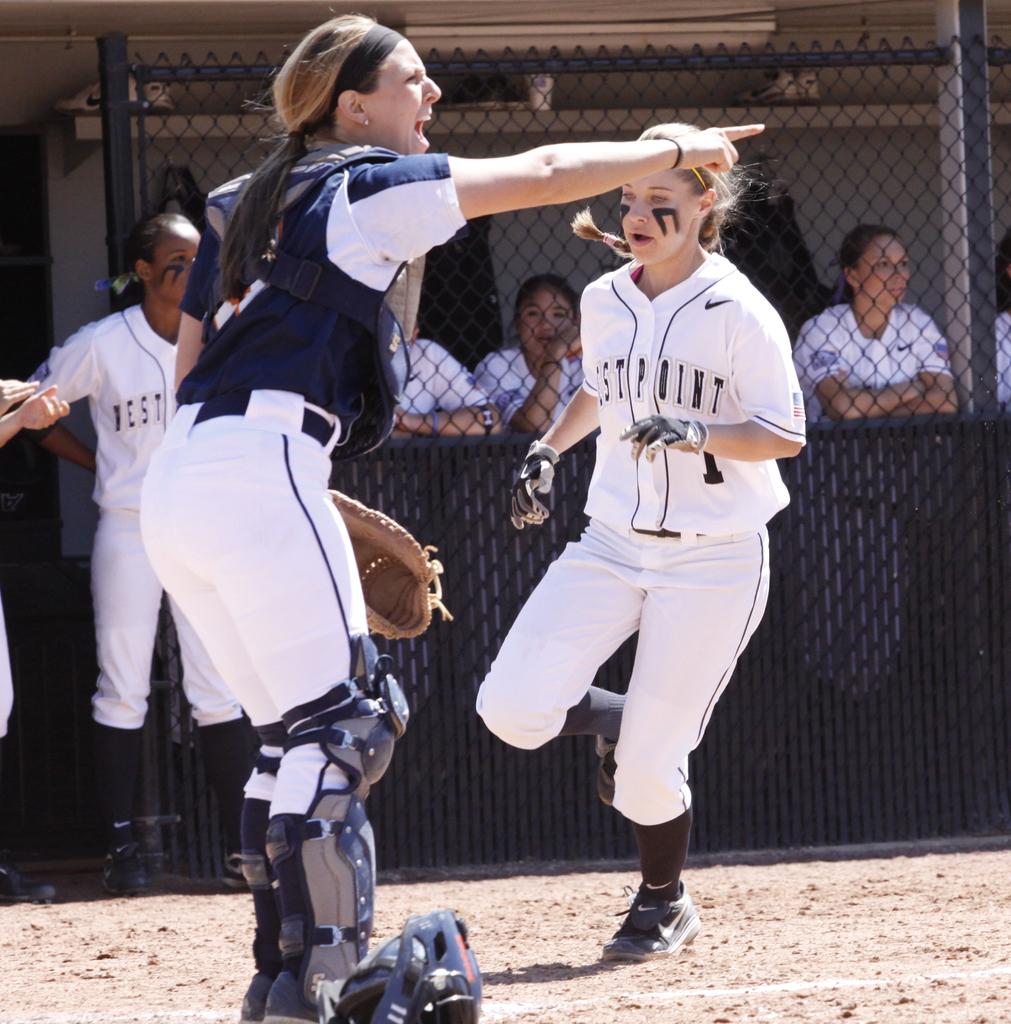What is the name of the baseball team the runner plays for?
Give a very brief answer. Westpoint. Does it look like the baserunner is wearing number 1?
Make the answer very short. Yes. 